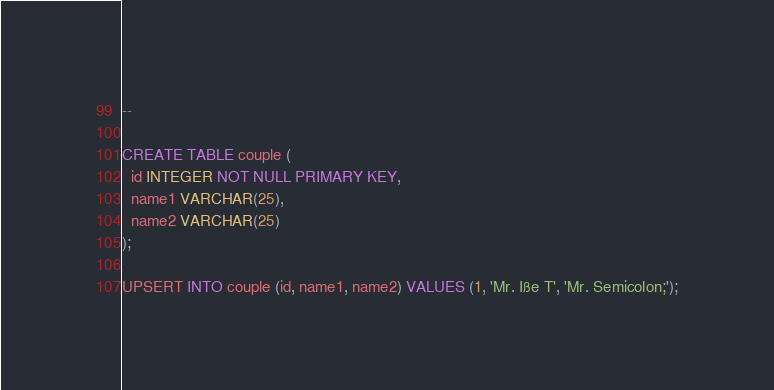Convert code to text. <code><loc_0><loc_0><loc_500><loc_500><_SQL_>--

CREATE TABLE couple (
  id INTEGER NOT NULL PRIMARY KEY,
  name1 VARCHAR(25),
  name2 VARCHAR(25)
);

UPSERT INTO couple (id, name1, name2) VALUES (1, 'Mr. Iße T', 'Mr. Semicolon;');</code> 